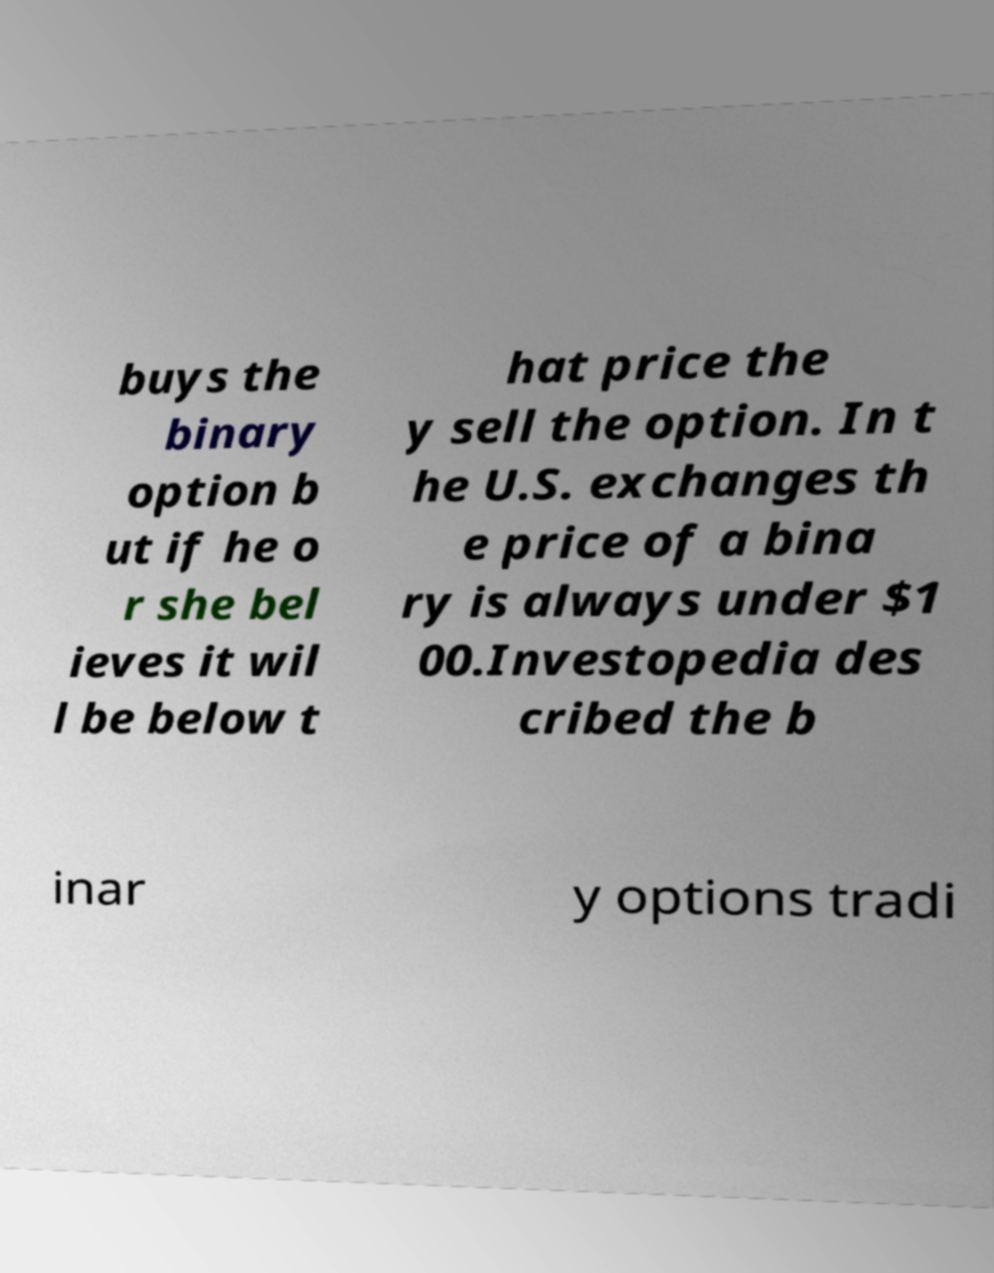For documentation purposes, I need the text within this image transcribed. Could you provide that? buys the binary option b ut if he o r she bel ieves it wil l be below t hat price the y sell the option. In t he U.S. exchanges th e price of a bina ry is always under $1 00.Investopedia des cribed the b inar y options tradi 